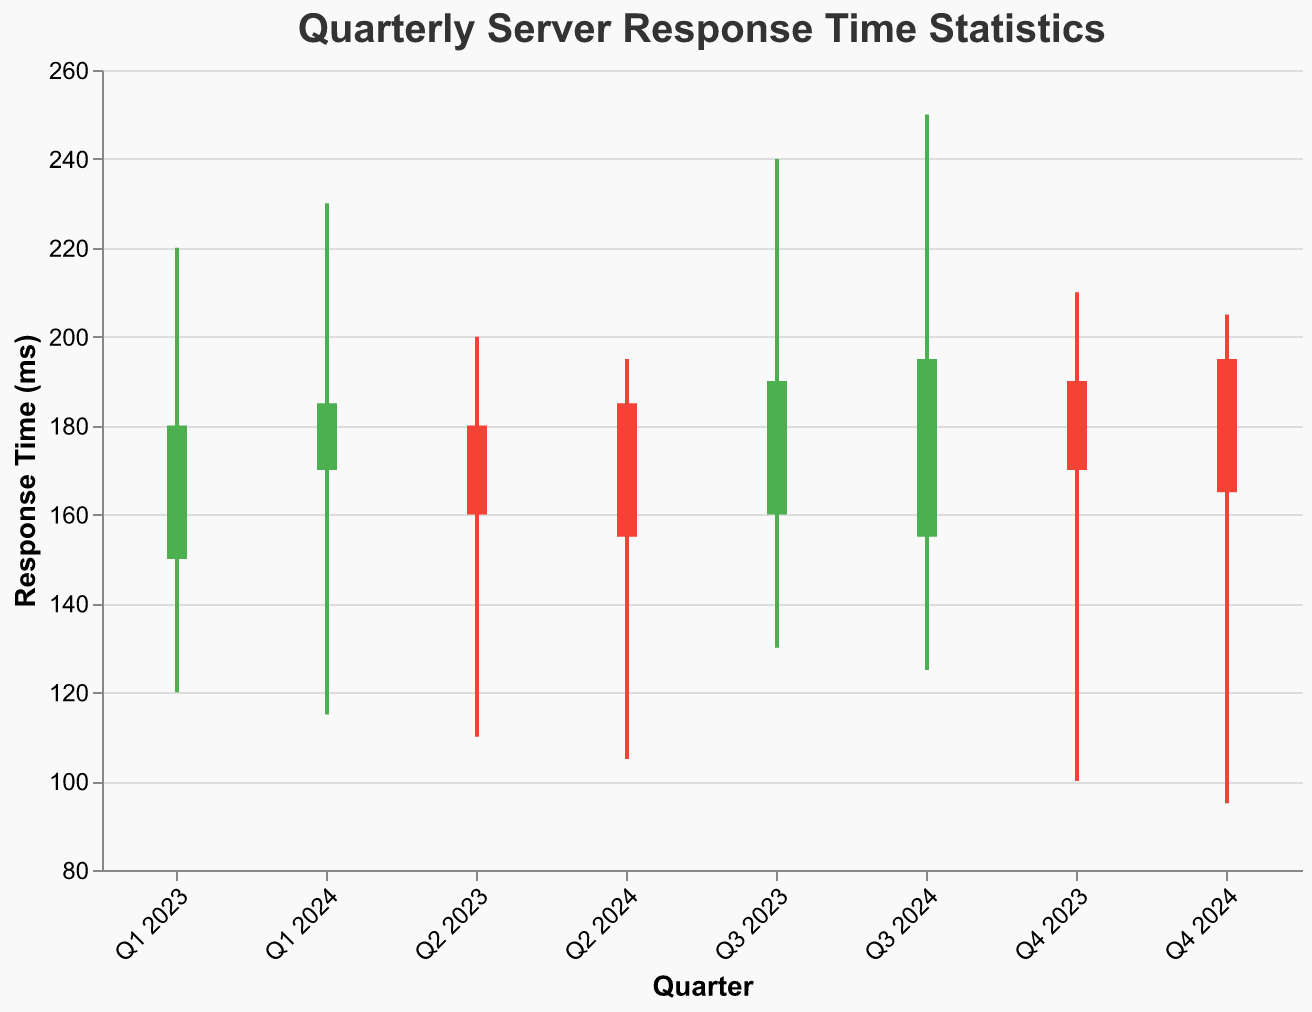What is the title of the chart? The title is displayed at the top of the chart and clearly states the subject of the chart. "Quarterly Server Response Time Statistics" is the text visible.
Answer: Quarterly Server Response Time Statistics Which quarter had the highest maximum response time? To find the highest maximum response time, we look for the tallest line (representing the max value) in the chart. Q3 2024 has a max value of 250 ms.
Answer: Q3 2024 Compare the average response times of Q2 2023 and Q2 2024. Which quarter had a higher average response time? By comparing the Avg values for Q2 2023 (162 ms) and Q2 2024 (160 ms), we see that Q2 2023 had a slightly higher average response time.
Answer: Q2 2023 Which quarters had a decrease in server response time from the opening to the closing value? To identify this, we look for bars that start higher (Open) and end lower (Close). These are Q2 2023, Q4 2023, Q2 2024, and Q4 2024.
Answer: Q2 2023, Q4 2023, Q2 2024, Q4 2024 What is the average server response time in Q1 2024? The chart displays the average response time as a data point. For Q1 2024, this value is 175 ms.
Answer: 175 ms Which quarter showed the greatest range between the minimum and maximum response times? The range can be seen by the length of the line from Min to Max. For Q3 2024, the range is 250 - 125 = 125 ms, which is the greatest.
Answer: Q3 2024 What is the closing response time of Q1 2023? The closing value for Q1 2023 is shown at the top of the respective bar. It is 180 ms.
Answer: 180 ms Compare the maximum response times of Q1 2024 and Q2 2024. Which one is higher and by how much? Q1 2024 has a maximum of 230 ms and Q2 2024 has a maximum of 195 ms. The difference is 230 - 195 = 35 ms. Q1 2024 is higher by 35 ms.
Answer: Q1 2024 by 35 ms Which quarter has the minimum response time value of 95 ms? By looking at the Min values on the y-axis, Q4 2024 has the minimum response time of 95 ms.
Answer: Q4 2024 